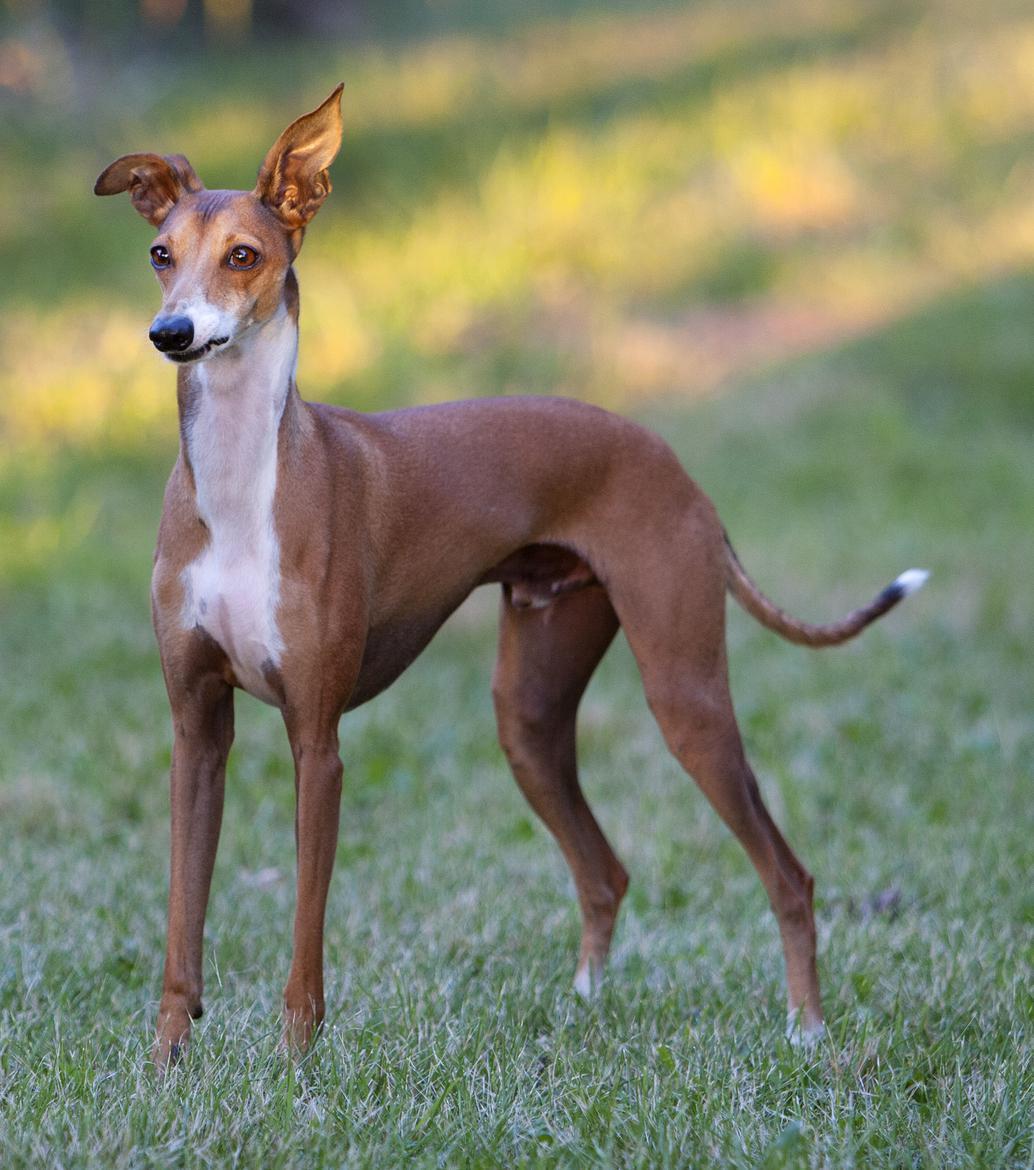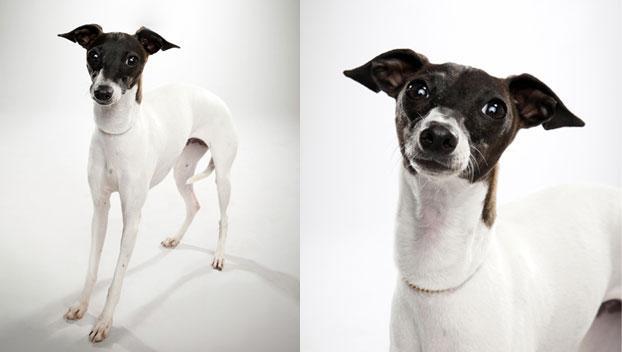The first image is the image on the left, the second image is the image on the right. Assess this claim about the two images: "Left image contains more than one dog, with at least one wearing a collar.". Correct or not? Answer yes or no. No. The first image is the image on the left, the second image is the image on the right. Examine the images to the left and right. Is the description "A dog is sitting on a cloth." accurate? Answer yes or no. No. 